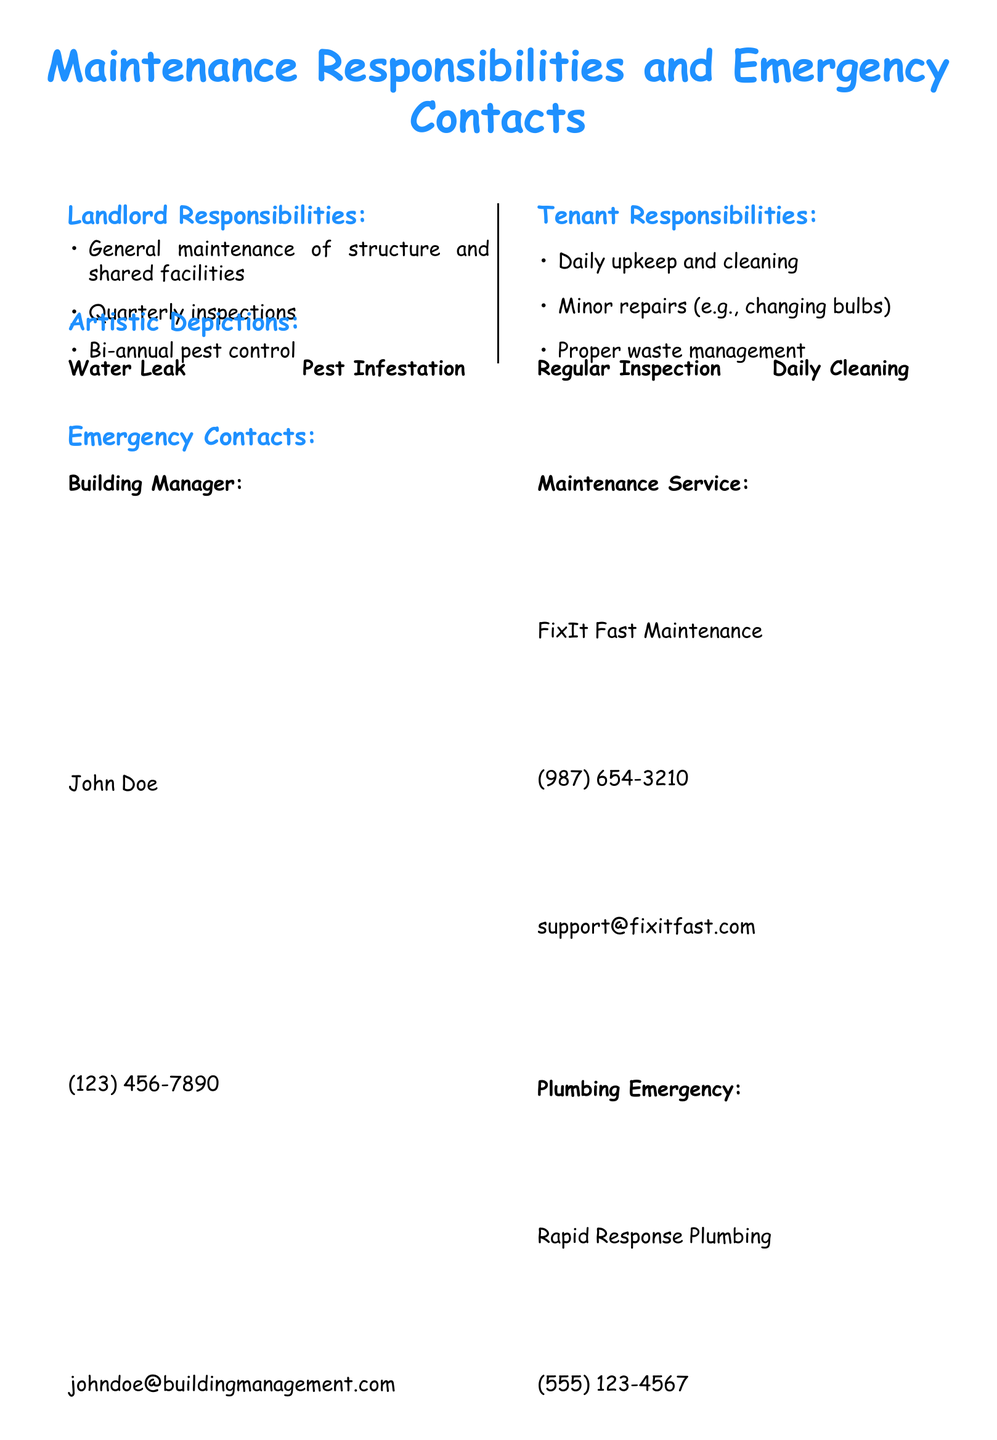What are the landlord's main responsibilities? The document outlines the specific maintenance duties of the landlord, including general maintenance of structure and shared facilities, quarterly inspections, and bi-annual pest control.
Answer: General maintenance of structure and shared facilities, quarterly inspections, bi-annual pest control Who is listed as the building manager? The document specifies the name of the building manager as well as their contact information.
Answer: John Doe What is the contact number for the maintenance service? The document provides the contact number for FixIt Fast Maintenance, detailing their service offering.
Answer: (987) 654-3210 What type of emergency does Bright Sparks Electricians handle? The document mentions emergency service providers, specifying the type of emergency each one covers, including Bright Sparks Electricians for electrical issues.
Answer: Electrical Emergency How often does the landlord conduct inspections? The lease agreement states how often the landlord is expected to check the property, which is a significant detail of the maintenance responsibilities.
Answer: Quarterly inspections What is the tenant's responsibility regarding waste? The document clearly describes that proper waste management is one of the tenant's responsibilities, emphasizing their role in upkeep.
Answer: Proper waste management Which emergency contact service handles plumbing issues? The document lists emergency service providers, including one specifically for plumbing emergencies.
Answer: Rapid Response Plumbing What are tenants responsible for in terms of repairs? The document mentions that tenants are responsible for certain types of repairs as part of their maintenance responsibilities.
Answer: Minor repairs (e.g., changing bulbs) 